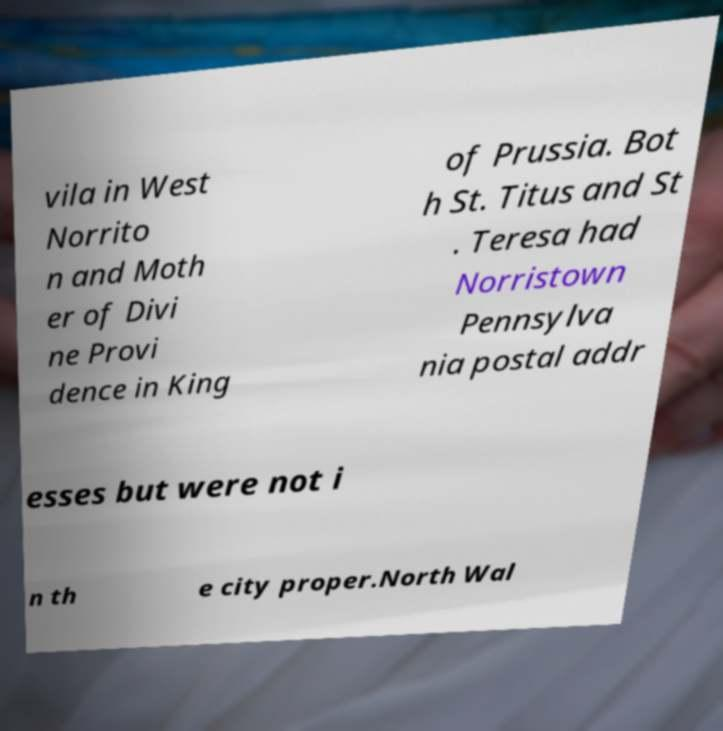I need the written content from this picture converted into text. Can you do that? vila in West Norrito n and Moth er of Divi ne Provi dence in King of Prussia. Bot h St. Titus and St . Teresa had Norristown Pennsylva nia postal addr esses but were not i n th e city proper.North Wal 